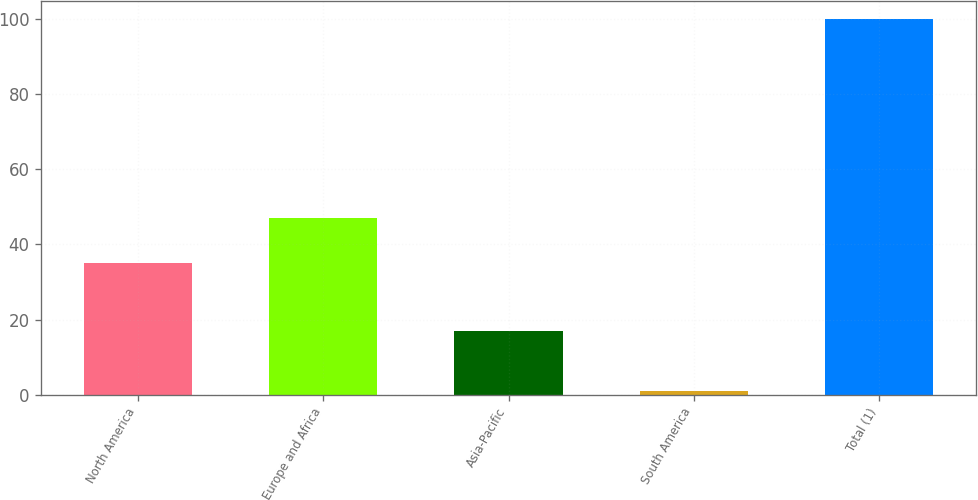Convert chart to OTSL. <chart><loc_0><loc_0><loc_500><loc_500><bar_chart><fcel>North America<fcel>Europe and Africa<fcel>Asia-Pacific<fcel>South America<fcel>Total (1)<nl><fcel>35<fcel>47<fcel>17<fcel>1<fcel>100<nl></chart> 